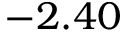Convert formula to latex. <formula><loc_0><loc_0><loc_500><loc_500>- 2 . 4 0</formula> 